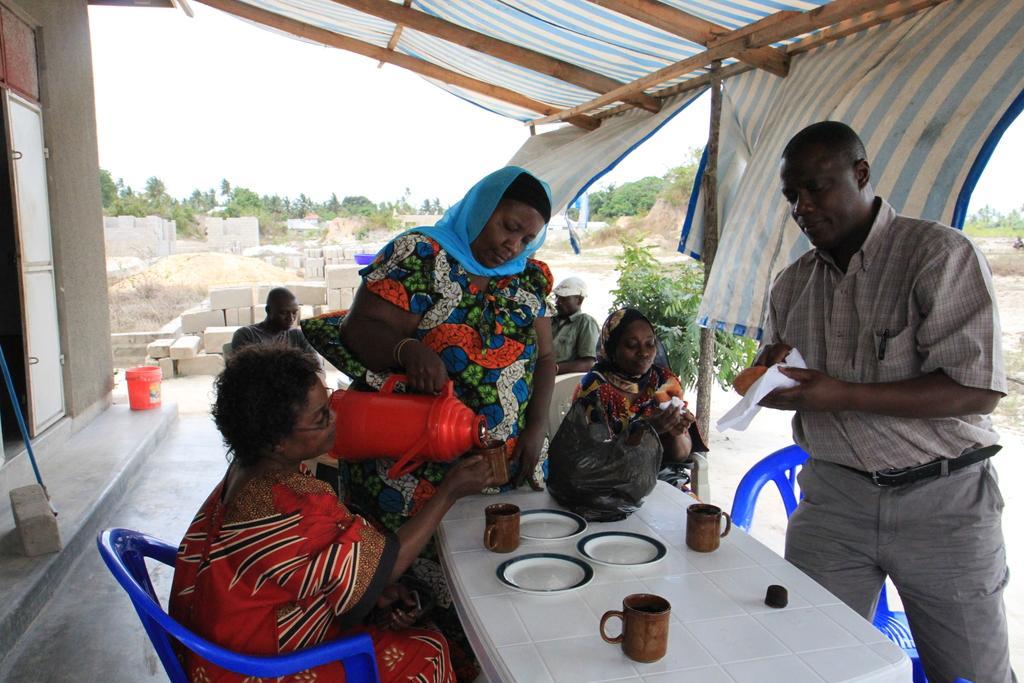In one or two sentences, can you explain what this image depicts? In this picture I can see there are few people sitting in the chairs and there is a table in front of them, there are plates, glasses and there is a woman standing and pouring water in the glass. There is a man standing and he is holding something. In the backdrop there are few people sitting and in the backdrop there are plants, trees, bricks, sand and the sky is clear. 